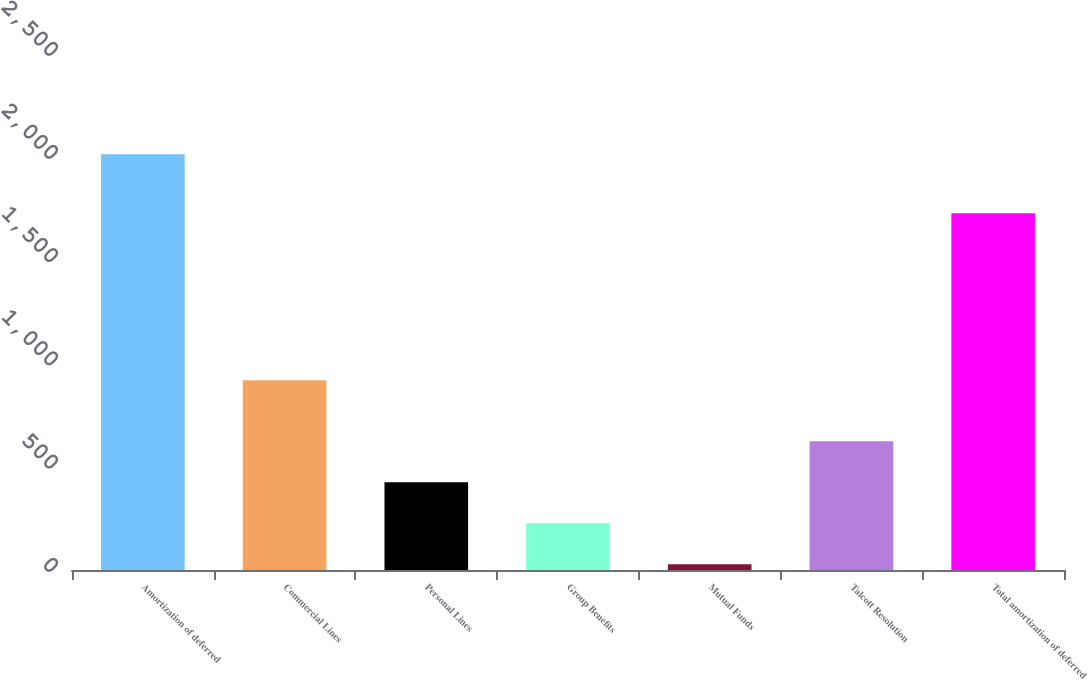<chart> <loc_0><loc_0><loc_500><loc_500><bar_chart><fcel>Amortization of deferred<fcel>Commercial Lines<fcel>Personal Lines<fcel>Group Benefits<fcel>Mutual Funds<fcel>Talcott Resolution<fcel>Total amortization of deferred<nl><fcel>2014<fcel>919<fcel>425.2<fcel>226.6<fcel>28<fcel>623.8<fcel>1729<nl></chart> 